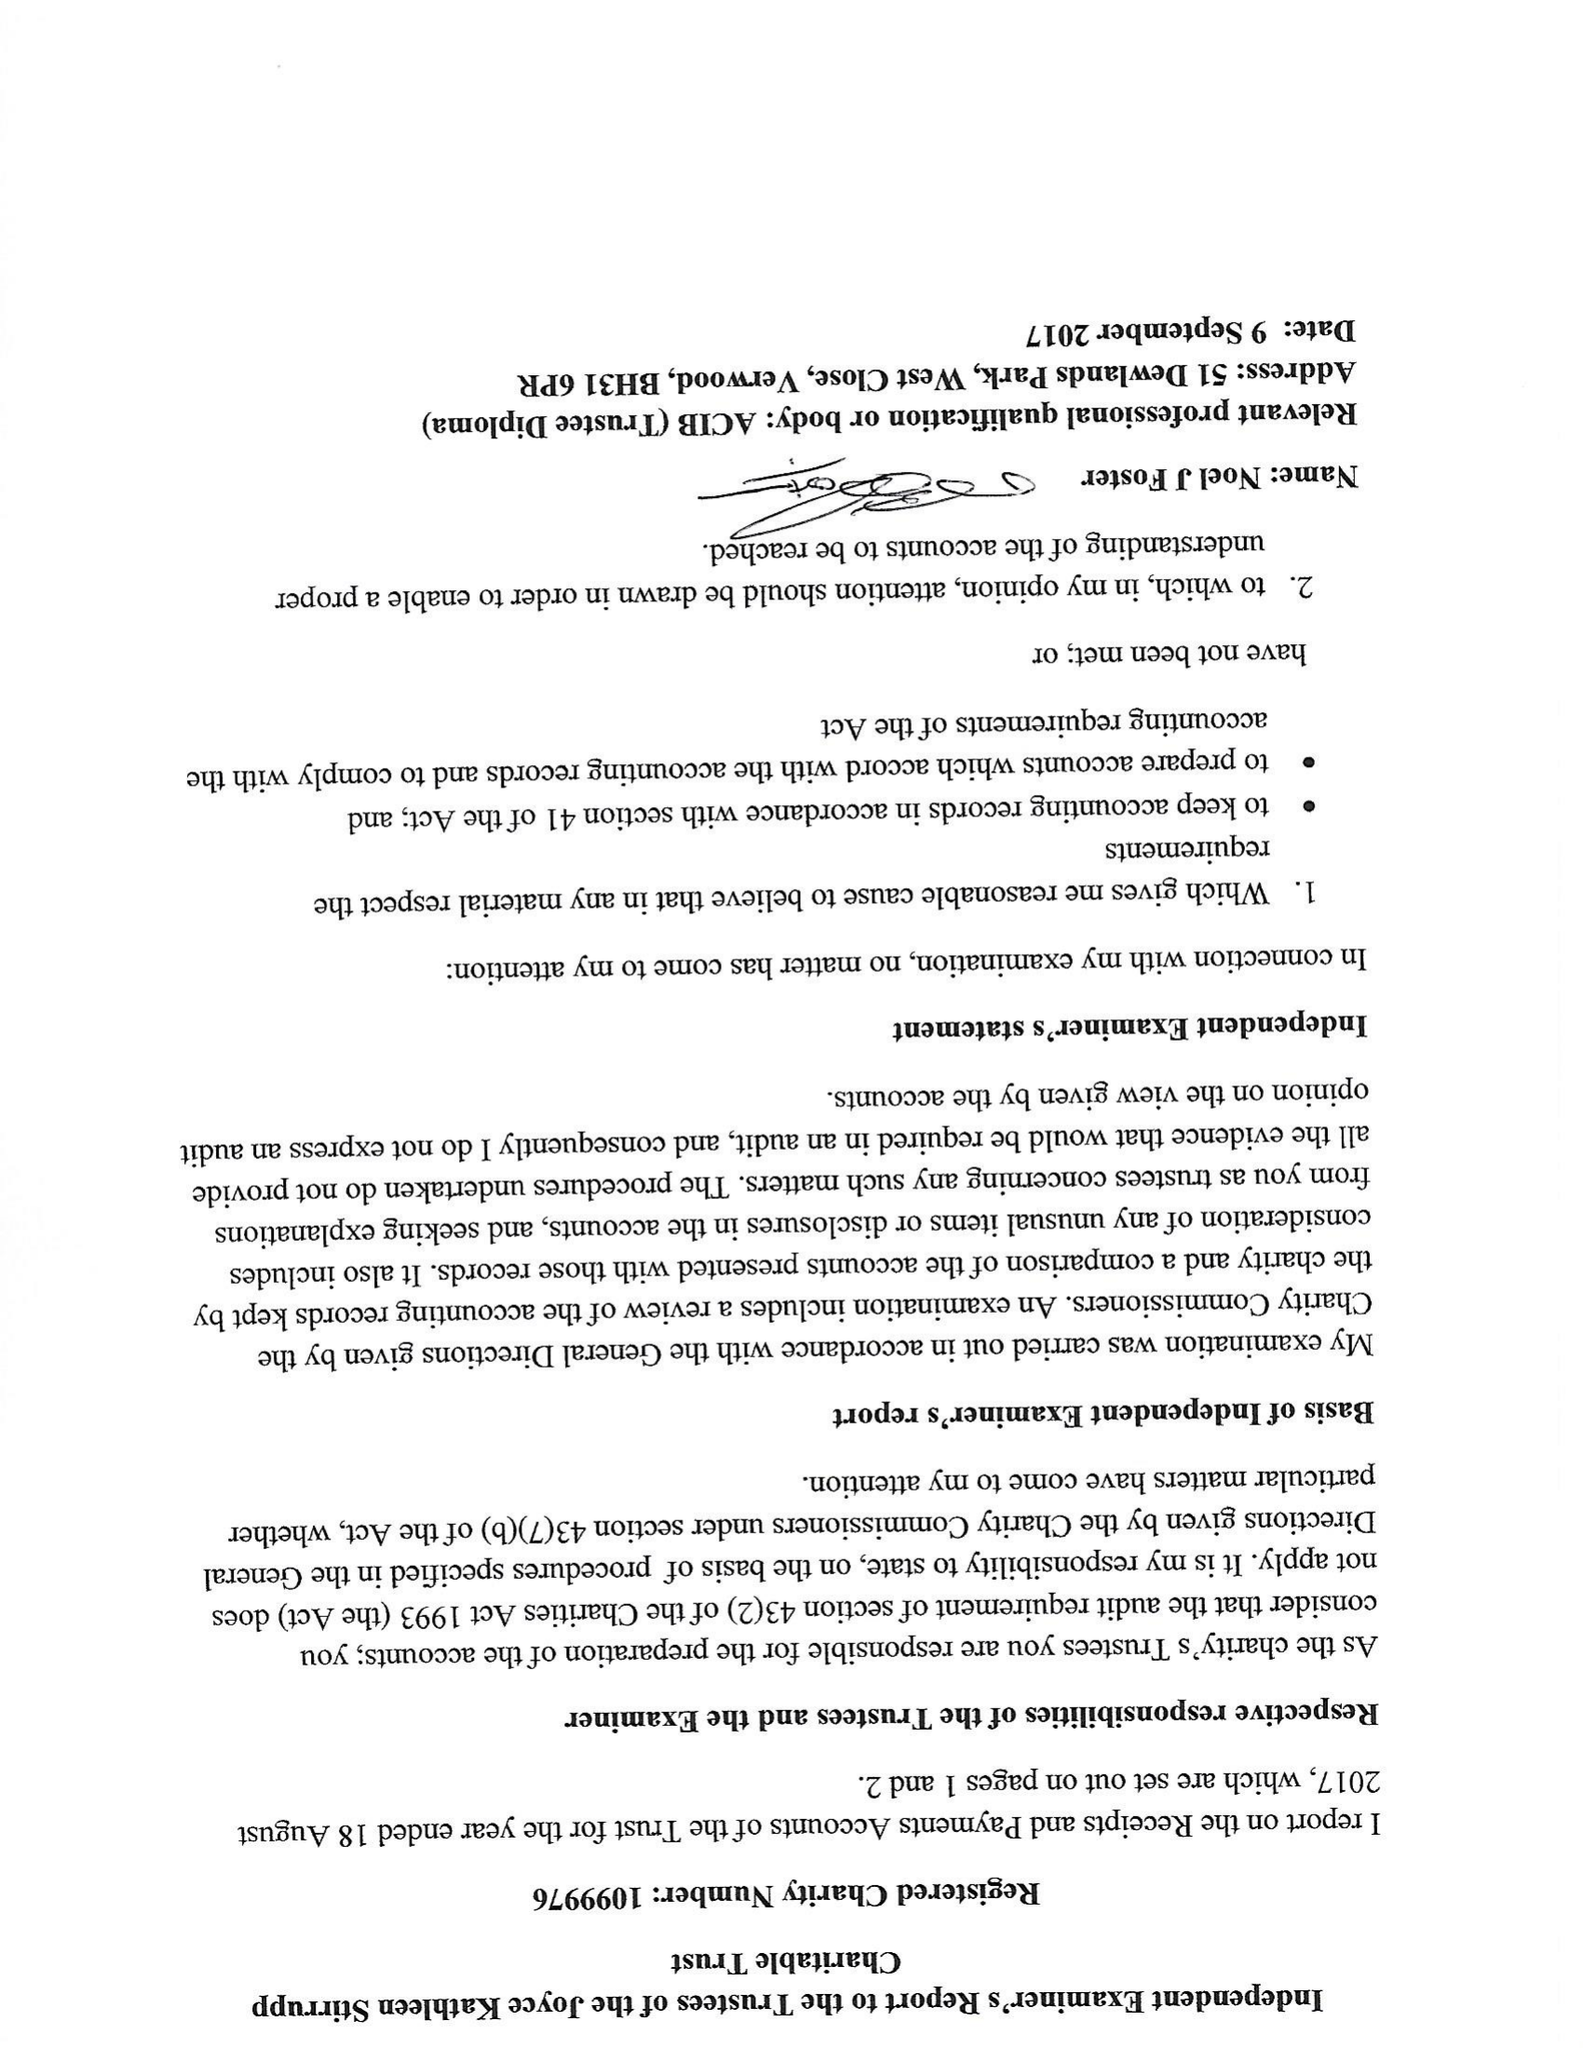What is the value for the address__postcode?
Answer the question using a single word or phrase. BS2 0PT 